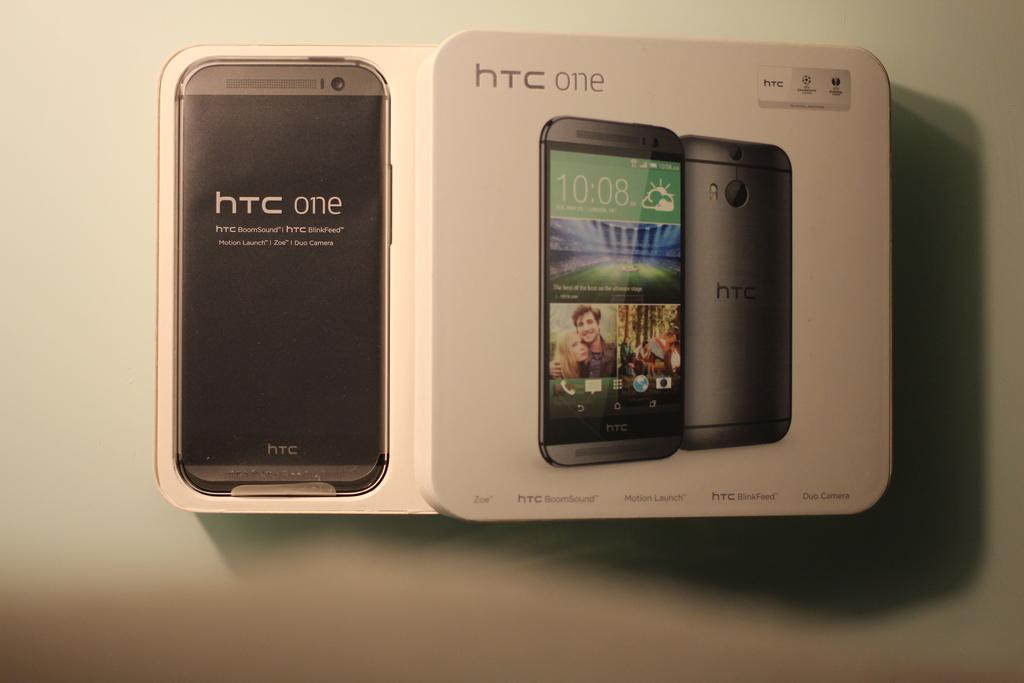Provide a one-sentence caption for the provided image. A box containing an HTC One cell phone that is opened and displaying the product inside. 